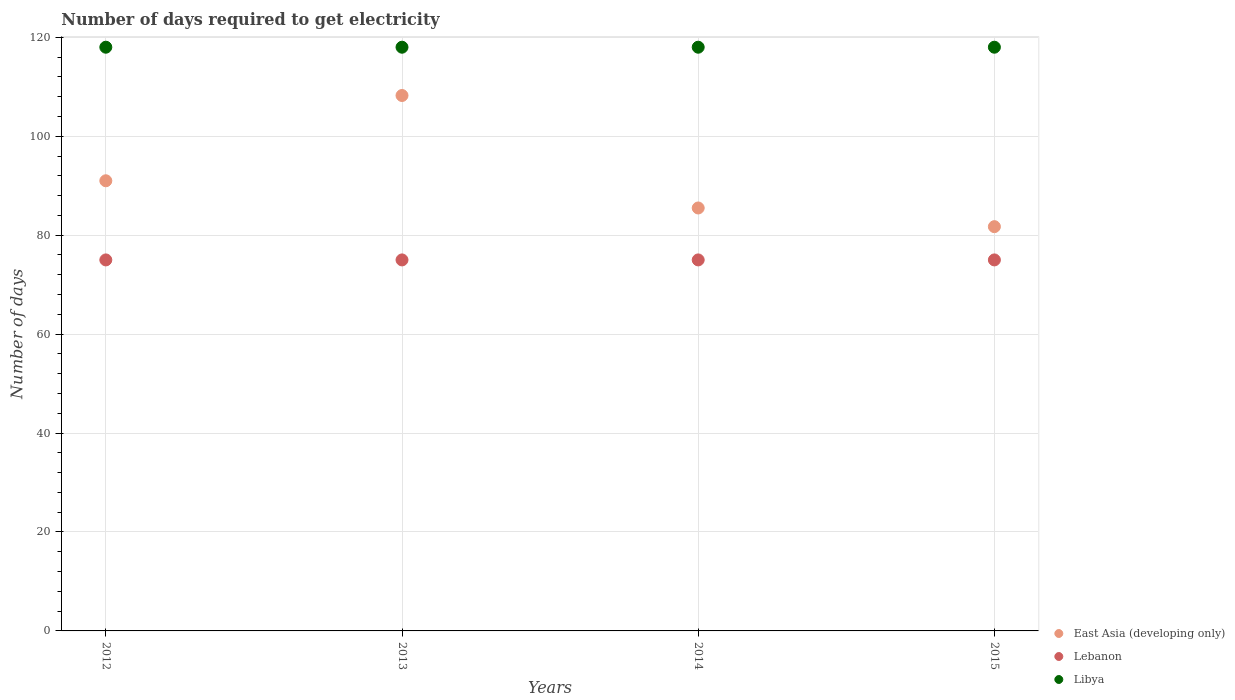How many different coloured dotlines are there?
Offer a very short reply. 3. Is the number of dotlines equal to the number of legend labels?
Provide a succinct answer. Yes. What is the number of days required to get electricity in in Lebanon in 2014?
Keep it short and to the point. 75. Across all years, what is the maximum number of days required to get electricity in in Lebanon?
Ensure brevity in your answer.  75. Across all years, what is the minimum number of days required to get electricity in in Libya?
Your answer should be compact. 118. In which year was the number of days required to get electricity in in Libya minimum?
Ensure brevity in your answer.  2012. What is the total number of days required to get electricity in in Libya in the graph?
Your answer should be compact. 472. What is the difference between the number of days required to get electricity in in Libya in 2015 and the number of days required to get electricity in in East Asia (developing only) in 2014?
Offer a very short reply. 32.5. What is the average number of days required to get electricity in in Libya per year?
Keep it short and to the point. 118. In the year 2014, what is the difference between the number of days required to get electricity in in Libya and number of days required to get electricity in in Lebanon?
Offer a terse response. 43. In how many years, is the number of days required to get electricity in in Lebanon greater than 24 days?
Provide a succinct answer. 4. Is the number of days required to get electricity in in East Asia (developing only) in 2012 less than that in 2014?
Make the answer very short. No. Is the difference between the number of days required to get electricity in in Libya in 2012 and 2015 greater than the difference between the number of days required to get electricity in in Lebanon in 2012 and 2015?
Make the answer very short. No. What is the difference between the highest and the second highest number of days required to get electricity in in East Asia (developing only)?
Ensure brevity in your answer.  17.24. Is the sum of the number of days required to get electricity in in Lebanon in 2013 and 2015 greater than the maximum number of days required to get electricity in in East Asia (developing only) across all years?
Provide a succinct answer. Yes. Is it the case that in every year, the sum of the number of days required to get electricity in in Lebanon and number of days required to get electricity in in Libya  is greater than the number of days required to get electricity in in East Asia (developing only)?
Your answer should be very brief. Yes. Does the number of days required to get electricity in in Lebanon monotonically increase over the years?
Provide a short and direct response. No. Is the number of days required to get electricity in in Lebanon strictly less than the number of days required to get electricity in in East Asia (developing only) over the years?
Keep it short and to the point. Yes. Where does the legend appear in the graph?
Give a very brief answer. Bottom right. How many legend labels are there?
Give a very brief answer. 3. How are the legend labels stacked?
Provide a succinct answer. Vertical. What is the title of the graph?
Your response must be concise. Number of days required to get electricity. What is the label or title of the Y-axis?
Ensure brevity in your answer.  Number of days. What is the Number of days of East Asia (developing only) in 2012?
Offer a terse response. 91. What is the Number of days in Lebanon in 2012?
Offer a very short reply. 75. What is the Number of days in Libya in 2012?
Your answer should be compact. 118. What is the Number of days in East Asia (developing only) in 2013?
Offer a terse response. 108.24. What is the Number of days of Lebanon in 2013?
Keep it short and to the point. 75. What is the Number of days in Libya in 2013?
Ensure brevity in your answer.  118. What is the Number of days of East Asia (developing only) in 2014?
Offer a very short reply. 85.5. What is the Number of days of Lebanon in 2014?
Offer a very short reply. 75. What is the Number of days of Libya in 2014?
Your answer should be compact. 118. What is the Number of days in East Asia (developing only) in 2015?
Ensure brevity in your answer.  81.72. What is the Number of days in Libya in 2015?
Your answer should be compact. 118. Across all years, what is the maximum Number of days in East Asia (developing only)?
Your answer should be compact. 108.24. Across all years, what is the maximum Number of days of Lebanon?
Your answer should be compact. 75. Across all years, what is the maximum Number of days of Libya?
Your response must be concise. 118. Across all years, what is the minimum Number of days of East Asia (developing only)?
Give a very brief answer. 81.72. Across all years, what is the minimum Number of days in Lebanon?
Your answer should be very brief. 75. Across all years, what is the minimum Number of days of Libya?
Your answer should be compact. 118. What is the total Number of days of East Asia (developing only) in the graph?
Keep it short and to the point. 366.46. What is the total Number of days in Lebanon in the graph?
Provide a short and direct response. 300. What is the total Number of days in Libya in the graph?
Make the answer very short. 472. What is the difference between the Number of days in East Asia (developing only) in 2012 and that in 2013?
Make the answer very short. -17.24. What is the difference between the Number of days of Libya in 2012 and that in 2013?
Make the answer very short. 0. What is the difference between the Number of days in East Asia (developing only) in 2012 and that in 2014?
Your answer should be compact. 5.5. What is the difference between the Number of days of East Asia (developing only) in 2012 and that in 2015?
Offer a very short reply. 9.28. What is the difference between the Number of days of Lebanon in 2012 and that in 2015?
Your answer should be very brief. 0. What is the difference between the Number of days of Libya in 2012 and that in 2015?
Provide a succinct answer. 0. What is the difference between the Number of days in East Asia (developing only) in 2013 and that in 2014?
Give a very brief answer. 22.74. What is the difference between the Number of days in East Asia (developing only) in 2013 and that in 2015?
Offer a terse response. 26.51. What is the difference between the Number of days in Libya in 2013 and that in 2015?
Provide a succinct answer. 0. What is the difference between the Number of days of East Asia (developing only) in 2014 and that in 2015?
Provide a succinct answer. 3.78. What is the difference between the Number of days of Lebanon in 2012 and the Number of days of Libya in 2013?
Give a very brief answer. -43. What is the difference between the Number of days of East Asia (developing only) in 2012 and the Number of days of Lebanon in 2014?
Your answer should be very brief. 16. What is the difference between the Number of days of East Asia (developing only) in 2012 and the Number of days of Libya in 2014?
Provide a short and direct response. -27. What is the difference between the Number of days of Lebanon in 2012 and the Number of days of Libya in 2014?
Provide a short and direct response. -43. What is the difference between the Number of days of Lebanon in 2012 and the Number of days of Libya in 2015?
Offer a terse response. -43. What is the difference between the Number of days in East Asia (developing only) in 2013 and the Number of days in Lebanon in 2014?
Keep it short and to the point. 33.24. What is the difference between the Number of days in East Asia (developing only) in 2013 and the Number of days in Libya in 2014?
Offer a very short reply. -9.76. What is the difference between the Number of days in Lebanon in 2013 and the Number of days in Libya in 2014?
Offer a terse response. -43. What is the difference between the Number of days in East Asia (developing only) in 2013 and the Number of days in Lebanon in 2015?
Provide a succinct answer. 33.24. What is the difference between the Number of days of East Asia (developing only) in 2013 and the Number of days of Libya in 2015?
Your answer should be compact. -9.76. What is the difference between the Number of days in Lebanon in 2013 and the Number of days in Libya in 2015?
Offer a terse response. -43. What is the difference between the Number of days of East Asia (developing only) in 2014 and the Number of days of Lebanon in 2015?
Your response must be concise. 10.5. What is the difference between the Number of days of East Asia (developing only) in 2014 and the Number of days of Libya in 2015?
Make the answer very short. -32.5. What is the difference between the Number of days of Lebanon in 2014 and the Number of days of Libya in 2015?
Ensure brevity in your answer.  -43. What is the average Number of days of East Asia (developing only) per year?
Your answer should be compact. 91.62. What is the average Number of days of Libya per year?
Give a very brief answer. 118. In the year 2012, what is the difference between the Number of days of East Asia (developing only) and Number of days of Libya?
Ensure brevity in your answer.  -27. In the year 2012, what is the difference between the Number of days in Lebanon and Number of days in Libya?
Your answer should be very brief. -43. In the year 2013, what is the difference between the Number of days of East Asia (developing only) and Number of days of Lebanon?
Offer a terse response. 33.24. In the year 2013, what is the difference between the Number of days in East Asia (developing only) and Number of days in Libya?
Provide a succinct answer. -9.76. In the year 2013, what is the difference between the Number of days in Lebanon and Number of days in Libya?
Ensure brevity in your answer.  -43. In the year 2014, what is the difference between the Number of days in East Asia (developing only) and Number of days in Libya?
Your response must be concise. -32.5. In the year 2014, what is the difference between the Number of days in Lebanon and Number of days in Libya?
Offer a terse response. -43. In the year 2015, what is the difference between the Number of days of East Asia (developing only) and Number of days of Lebanon?
Provide a short and direct response. 6.72. In the year 2015, what is the difference between the Number of days of East Asia (developing only) and Number of days of Libya?
Ensure brevity in your answer.  -36.28. In the year 2015, what is the difference between the Number of days in Lebanon and Number of days in Libya?
Keep it short and to the point. -43. What is the ratio of the Number of days of East Asia (developing only) in 2012 to that in 2013?
Offer a terse response. 0.84. What is the ratio of the Number of days in Lebanon in 2012 to that in 2013?
Provide a short and direct response. 1. What is the ratio of the Number of days in East Asia (developing only) in 2012 to that in 2014?
Your response must be concise. 1.06. What is the ratio of the Number of days in East Asia (developing only) in 2012 to that in 2015?
Offer a terse response. 1.11. What is the ratio of the Number of days of Libya in 2012 to that in 2015?
Ensure brevity in your answer.  1. What is the ratio of the Number of days of East Asia (developing only) in 2013 to that in 2014?
Offer a terse response. 1.27. What is the ratio of the Number of days of Lebanon in 2013 to that in 2014?
Your answer should be very brief. 1. What is the ratio of the Number of days in Libya in 2013 to that in 2014?
Your answer should be very brief. 1. What is the ratio of the Number of days of East Asia (developing only) in 2013 to that in 2015?
Provide a succinct answer. 1.32. What is the ratio of the Number of days of Lebanon in 2013 to that in 2015?
Your answer should be very brief. 1. What is the ratio of the Number of days in Libya in 2013 to that in 2015?
Ensure brevity in your answer.  1. What is the ratio of the Number of days in East Asia (developing only) in 2014 to that in 2015?
Offer a terse response. 1.05. What is the ratio of the Number of days of Libya in 2014 to that in 2015?
Keep it short and to the point. 1. What is the difference between the highest and the second highest Number of days of East Asia (developing only)?
Provide a short and direct response. 17.24. What is the difference between the highest and the lowest Number of days in East Asia (developing only)?
Your answer should be compact. 26.51. What is the difference between the highest and the lowest Number of days in Lebanon?
Offer a terse response. 0. 